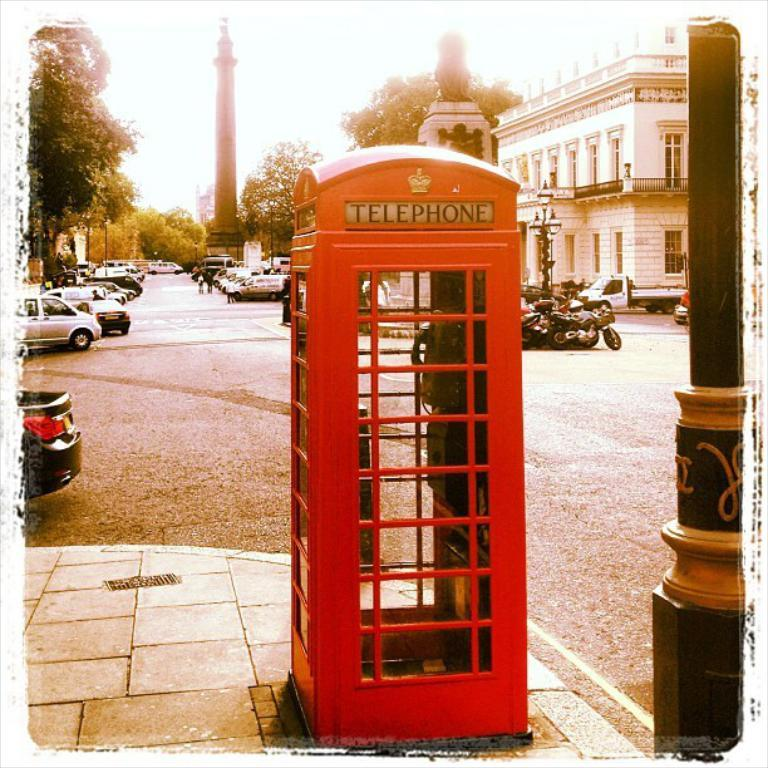<image>
Share a concise interpretation of the image provided. a telephone booth that is red in color 